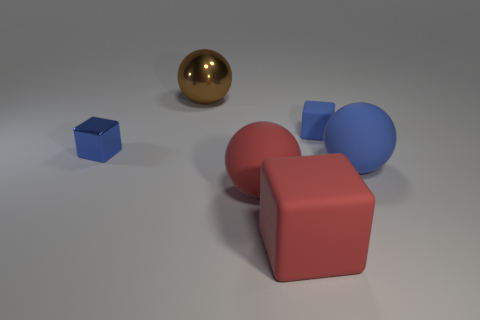There is a large red rubber object on the left side of the red block; what number of spheres are left of it?
Keep it short and to the point. 1. Is there a large ball of the same color as the tiny metal block?
Offer a very short reply. Yes. Is the blue matte sphere the same size as the blue metallic object?
Provide a short and direct response. No. Does the tiny shiny block have the same color as the small matte block?
Keep it short and to the point. Yes. The tiny blue cube on the left side of the large sphere behind the tiny metallic thing is made of what material?
Give a very brief answer. Metal. There is a big brown object that is the same shape as the big blue object; what material is it?
Ensure brevity in your answer.  Metal. There is a blue matte thing that is behind the blue shiny cube; does it have the same size as the big red matte cube?
Keep it short and to the point. No. How many rubber objects are blue things or large brown balls?
Offer a very short reply. 2. There is a thing that is both on the left side of the big red matte sphere and in front of the big brown shiny sphere; what is its material?
Give a very brief answer. Metal. Are the big red cube and the big blue thing made of the same material?
Keep it short and to the point. Yes. 